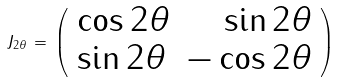<formula> <loc_0><loc_0><loc_500><loc_500>J _ { 2 \theta } \, = \, \left ( \begin{array} { l r } \cos { 2 \theta } & \sin { 2 \theta } \\ \sin { 2 \theta } & - \cos { 2 \theta } \\ \end{array} \right )</formula> 